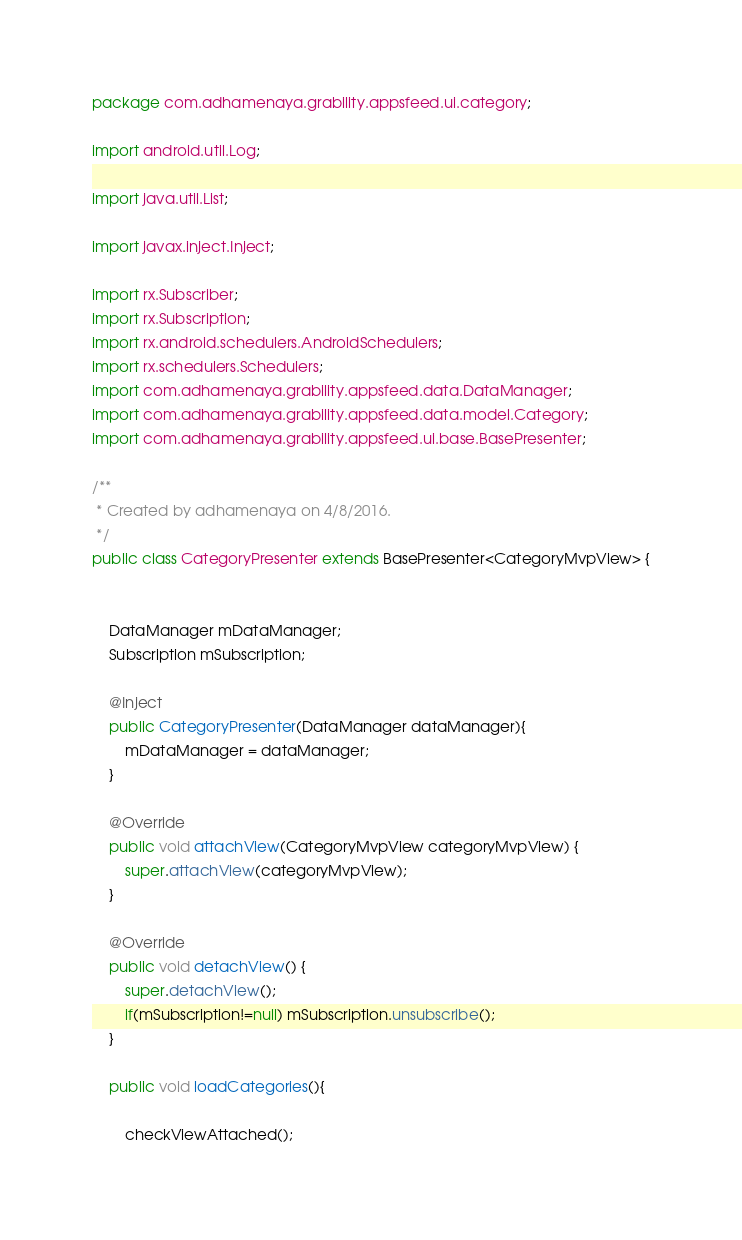<code> <loc_0><loc_0><loc_500><loc_500><_Java_>package com.adhamenaya.grability.appsfeed.ui.category;

import android.util.Log;

import java.util.List;

import javax.inject.Inject;

import rx.Subscriber;
import rx.Subscription;
import rx.android.schedulers.AndroidSchedulers;
import rx.schedulers.Schedulers;
import com.adhamenaya.grability.appsfeed.data.DataManager;
import com.adhamenaya.grability.appsfeed.data.model.Category;
import com.adhamenaya.grability.appsfeed.ui.base.BasePresenter;

/**
 * Created by adhamenaya on 4/8/2016.
 */
public class CategoryPresenter extends BasePresenter<CategoryMvpView> {


    DataManager mDataManager;
    Subscription mSubscription;

    @Inject
    public CategoryPresenter(DataManager dataManager){
        mDataManager = dataManager;
    }

    @Override
    public void attachView(CategoryMvpView categoryMvpView) {
        super.attachView(categoryMvpView);
    }

    @Override
    public void detachView() {
        super.detachView();
        if(mSubscription!=null) mSubscription.unsubscribe();
    }

    public void loadCategories(){

        checkViewAttached();
</code> 